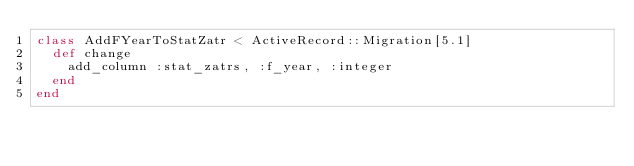<code> <loc_0><loc_0><loc_500><loc_500><_Ruby_>class AddFYearToStatZatr < ActiveRecord::Migration[5.1]
  def change
    add_column :stat_zatrs, :f_year, :integer
  end
end
</code> 